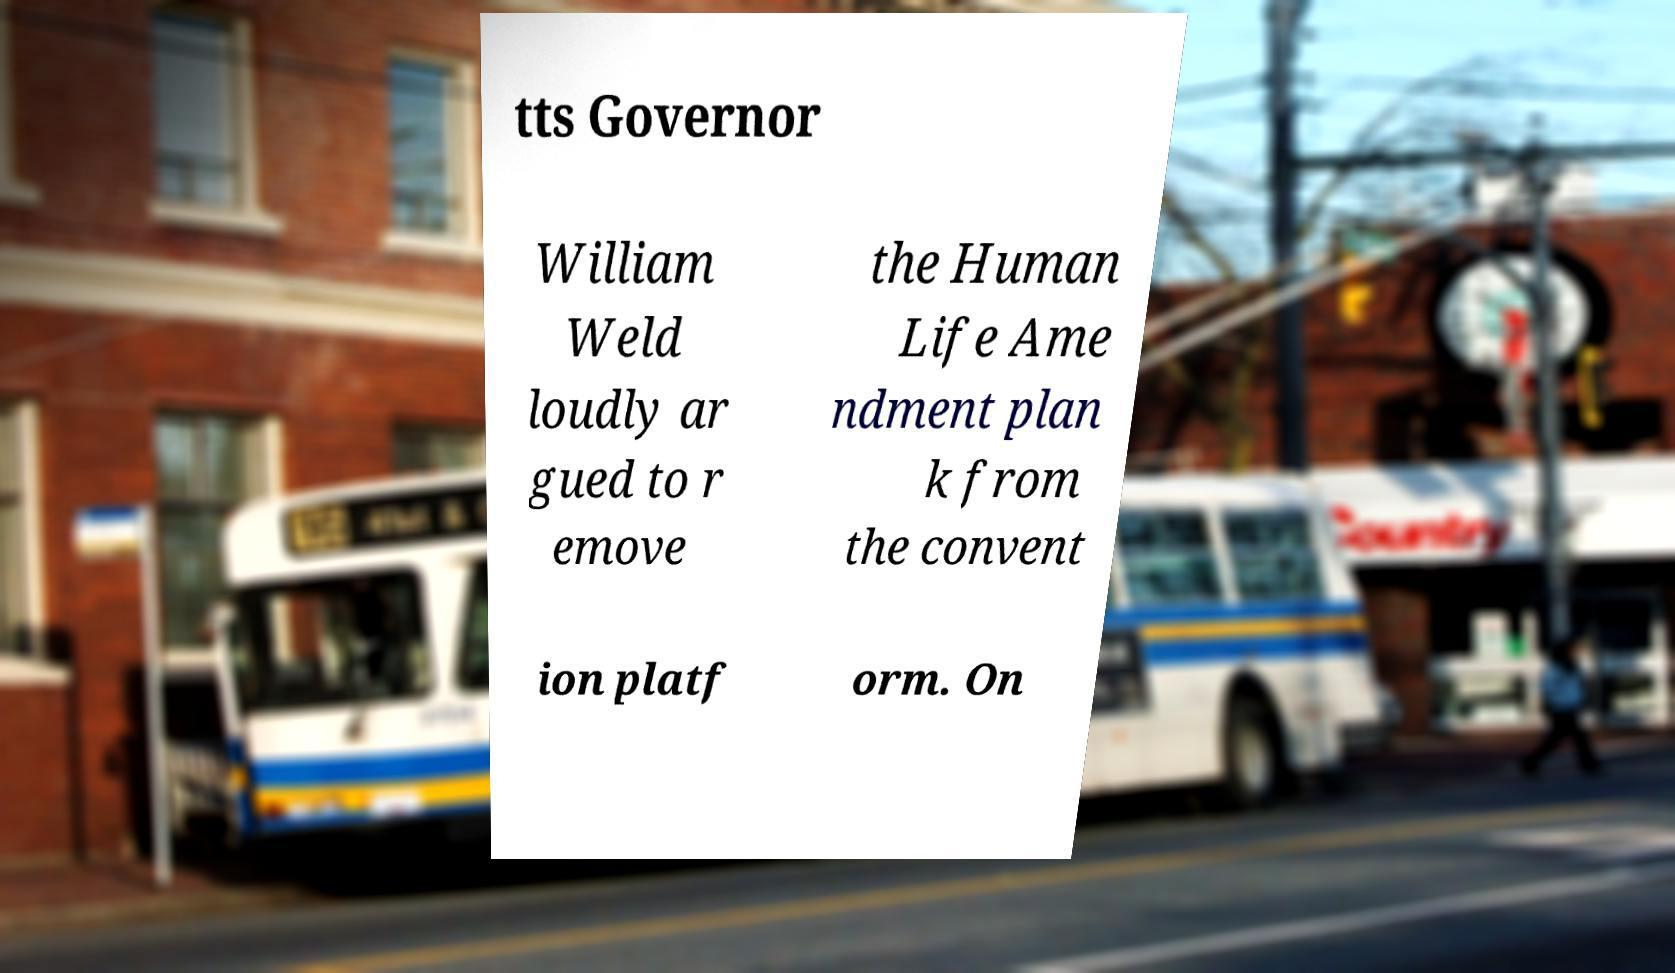Can you read and provide the text displayed in the image?This photo seems to have some interesting text. Can you extract and type it out for me? tts Governor William Weld loudly ar gued to r emove the Human Life Ame ndment plan k from the convent ion platf orm. On 